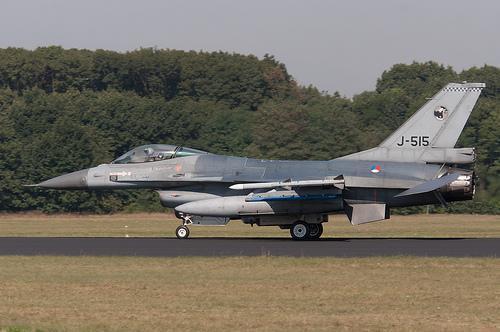How many fighter jets are there?
Give a very brief answer. 1. 